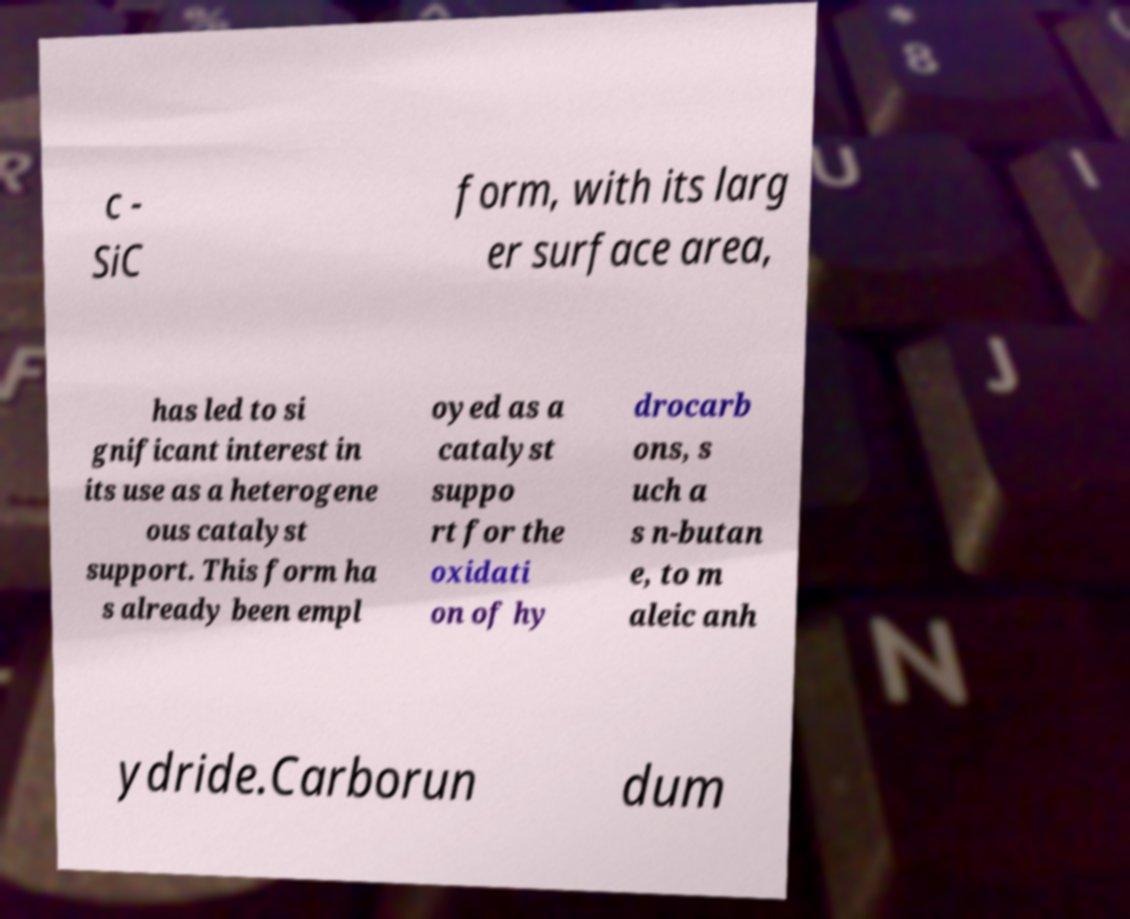I need the written content from this picture converted into text. Can you do that? c - SiC form, with its larg er surface area, has led to si gnificant interest in its use as a heterogene ous catalyst support. This form ha s already been empl oyed as a catalyst suppo rt for the oxidati on of hy drocarb ons, s uch a s n-butan e, to m aleic anh ydride.Carborun dum 